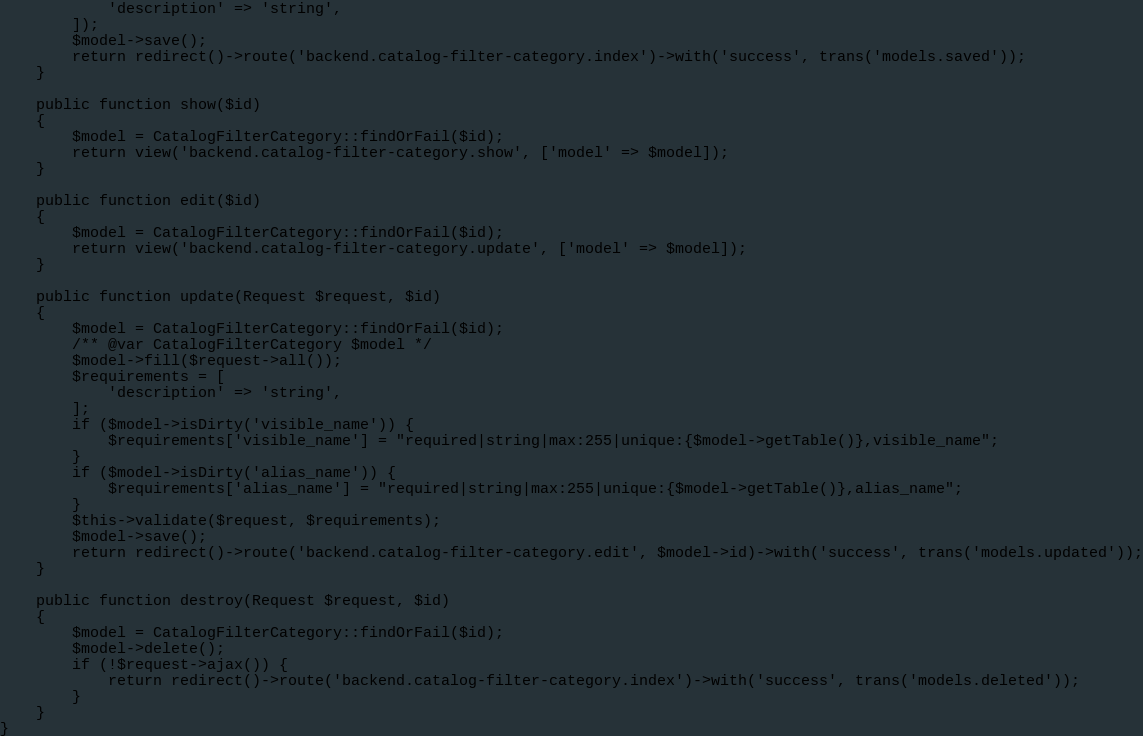Convert code to text. <code><loc_0><loc_0><loc_500><loc_500><_PHP_>            'description' => 'string',
        ]);
        $model->save();
        return redirect()->route('backend.catalog-filter-category.index')->with('success', trans('models.saved'));
    }

    public function show($id)
    {
        $model = CatalogFilterCategory::findOrFail($id);
        return view('backend.catalog-filter-category.show', ['model' => $model]);
    }

    public function edit($id)
    {
        $model = CatalogFilterCategory::findOrFail($id);
        return view('backend.catalog-filter-category.update', ['model' => $model]);
    }

    public function update(Request $request, $id)
    {
        $model = CatalogFilterCategory::findOrFail($id);
        /** @var CatalogFilterCategory $model */
        $model->fill($request->all());
        $requirements = [
            'description' => 'string',
        ];
        if ($model->isDirty('visible_name')) {
            $requirements['visible_name'] = "required|string|max:255|unique:{$model->getTable()},visible_name";
        }
        if ($model->isDirty('alias_name')) {
            $requirements['alias_name'] = "required|string|max:255|unique:{$model->getTable()},alias_name";
        }
        $this->validate($request, $requirements);
        $model->save();
        return redirect()->route('backend.catalog-filter-category.edit', $model->id)->with('success', trans('models.updated'));
    }

    public function destroy(Request $request, $id)
    {
        $model = CatalogFilterCategory::findOrFail($id);
        $model->delete();
        if (!$request->ajax()) {
            return redirect()->route('backend.catalog-filter-category.index')->with('success', trans('models.deleted'));
        }
    }
}
</code> 